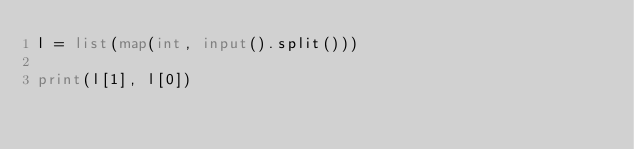<code> <loc_0><loc_0><loc_500><loc_500><_Python_>l = list(map(int, input().split()))

print(l[1], l[0])
</code> 